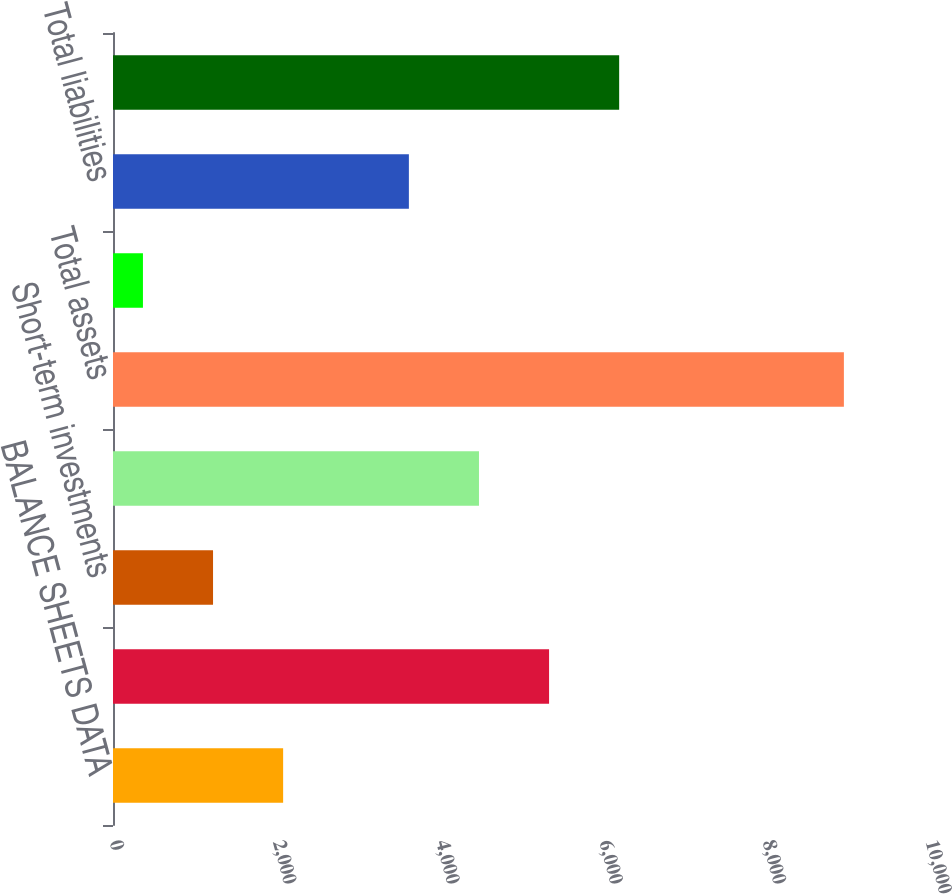Convert chart. <chart><loc_0><loc_0><loc_500><loc_500><bar_chart><fcel>BALANCE SHEETS DATA<fcel>Cash and cash equivalents<fcel>Short-term investments<fcel>Working capital<fcel>Total assets<fcel>Other long-term liabilities<fcel>Total liabilities<fcel>Total stockholders' equity<nl><fcel>2085<fcel>5344<fcel>1226<fcel>4485<fcel>8957<fcel>367<fcel>3626<fcel>6203<nl></chart> 